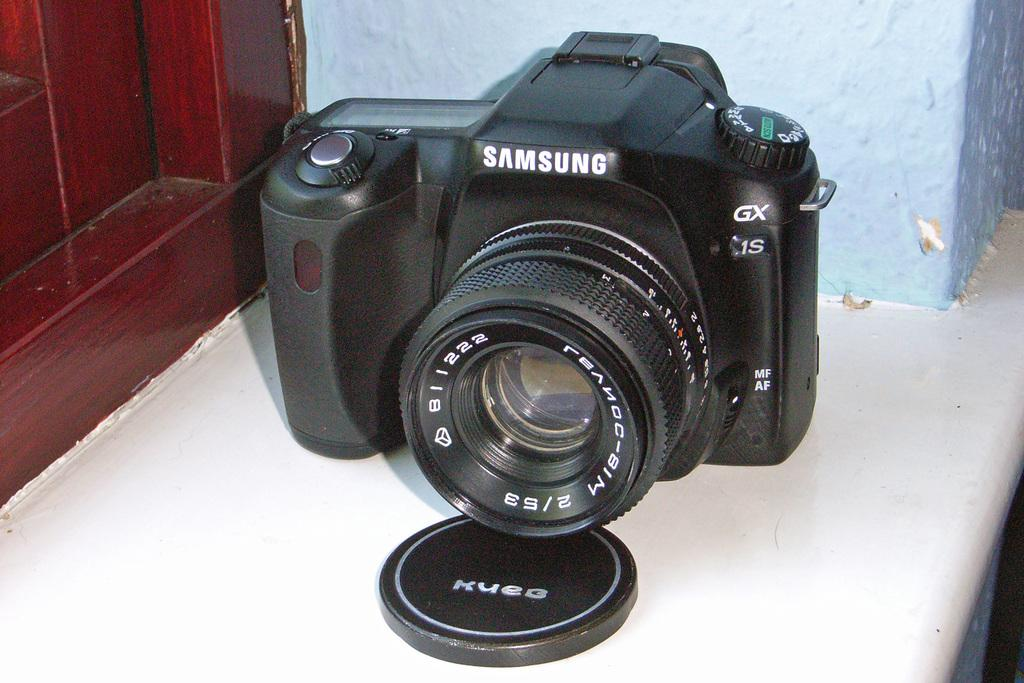What object is the main subject of the image? There is a camera in the image. What is the color of the camera? The camera is black in color. Where is the camera located in relation to other objects in the image? The camera is placed near a door. What brand is the camera? The word "Samsung" is written on the camera. What is covering the camera lens in the image? The camera has a cap. Can you see a rabbit fighting with a square in the image? No, there is no rabbit or square present in the image. 